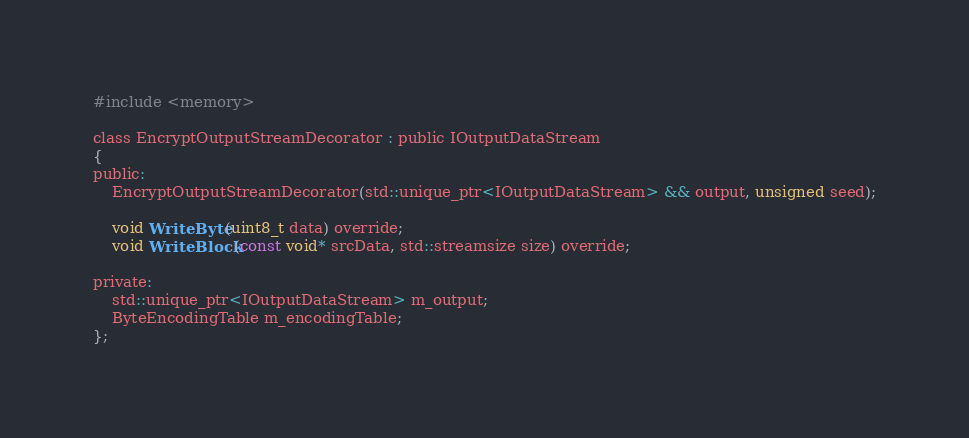Convert code to text. <code><loc_0><loc_0><loc_500><loc_500><_C_>#include <memory>

class EncryptOutputStreamDecorator : public IOutputDataStream
{
public:
	EncryptOutputStreamDecorator(std::unique_ptr<IOutputDataStream> && output, unsigned seed);

	void WriteByte(uint8_t data) override;
	void WriteBlock(const void* srcData, std::streamsize size) override;

private:
	std::unique_ptr<IOutputDataStream> m_output;
	ByteEncodingTable m_encodingTable;
};
</code> 